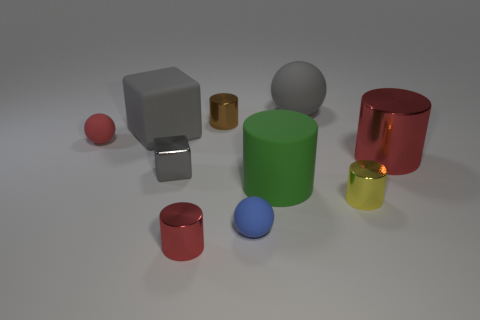What is the color of the big rubber object that is right of the blue thing and behind the green cylinder?
Keep it short and to the point. Gray. What is the material of the blue sphere that is the same size as the yellow thing?
Offer a terse response. Rubber. How many other things are there of the same material as the brown cylinder?
Give a very brief answer. 4. Is the color of the tiny rubber thing that is to the right of the brown shiny cylinder the same as the large cylinder that is right of the tiny yellow cylinder?
Ensure brevity in your answer.  No. There is a tiny red thing that is right of the tiny matte thing behind the large rubber cylinder; what is its shape?
Ensure brevity in your answer.  Cylinder. How many other things are the same color as the big metal cylinder?
Your answer should be compact. 2. Does the tiny cylinder behind the matte cylinder have the same material as the big gray thing in front of the tiny brown cylinder?
Provide a short and direct response. No. There is a rubber sphere left of the small gray object; what is its size?
Offer a terse response. Small. There is a blue object that is the same shape as the small red matte object; what is it made of?
Offer a terse response. Rubber. Is there any other thing that has the same size as the blue rubber sphere?
Your response must be concise. Yes. 